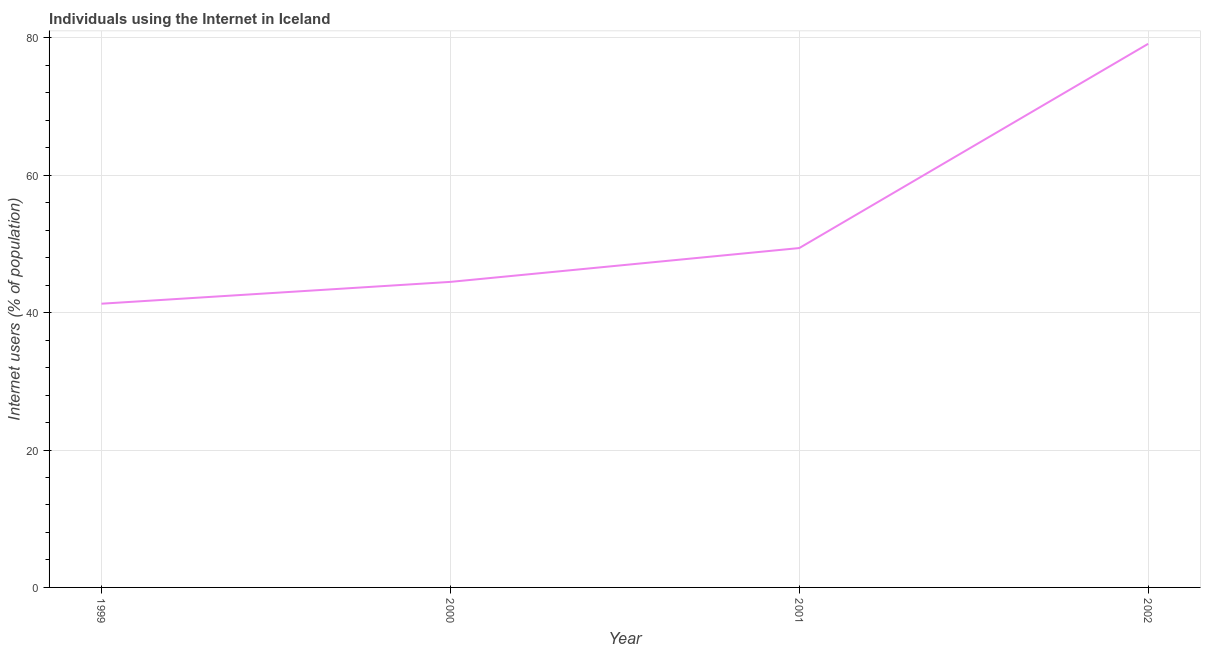What is the number of internet users in 2001?
Ensure brevity in your answer.  49.39. Across all years, what is the maximum number of internet users?
Give a very brief answer. 79.12. Across all years, what is the minimum number of internet users?
Ensure brevity in your answer.  41.29. What is the sum of the number of internet users?
Offer a very short reply. 214.28. What is the difference between the number of internet users in 1999 and 2000?
Ensure brevity in your answer.  -3.18. What is the average number of internet users per year?
Provide a short and direct response. 53.57. What is the median number of internet users?
Your answer should be compact. 46.93. In how many years, is the number of internet users greater than 16 %?
Your answer should be compact. 4. Do a majority of the years between 2001 and 2002 (inclusive) have number of internet users greater than 76 %?
Provide a succinct answer. No. What is the ratio of the number of internet users in 1999 to that in 2000?
Make the answer very short. 0.93. Is the number of internet users in 1999 less than that in 2000?
Your response must be concise. Yes. What is the difference between the highest and the second highest number of internet users?
Your answer should be very brief. 29.73. What is the difference between the highest and the lowest number of internet users?
Your response must be concise. 37.83. In how many years, is the number of internet users greater than the average number of internet users taken over all years?
Offer a very short reply. 1. Does the number of internet users monotonically increase over the years?
Your answer should be compact. Yes. How many years are there in the graph?
Make the answer very short. 4. What is the difference between two consecutive major ticks on the Y-axis?
Provide a short and direct response. 20. Does the graph contain any zero values?
Ensure brevity in your answer.  No. What is the title of the graph?
Offer a terse response. Individuals using the Internet in Iceland. What is the label or title of the X-axis?
Your answer should be very brief. Year. What is the label or title of the Y-axis?
Your answer should be compact. Internet users (% of population). What is the Internet users (% of population) of 1999?
Your answer should be compact. 41.29. What is the Internet users (% of population) in 2000?
Keep it short and to the point. 44.47. What is the Internet users (% of population) of 2001?
Provide a short and direct response. 49.39. What is the Internet users (% of population) of 2002?
Offer a very short reply. 79.12. What is the difference between the Internet users (% of population) in 1999 and 2000?
Your answer should be compact. -3.18. What is the difference between the Internet users (% of population) in 1999 and 2001?
Provide a short and direct response. -8.1. What is the difference between the Internet users (% of population) in 1999 and 2002?
Ensure brevity in your answer.  -37.83. What is the difference between the Internet users (% of population) in 2000 and 2001?
Ensure brevity in your answer.  -4.92. What is the difference between the Internet users (% of population) in 2000 and 2002?
Keep it short and to the point. -34.65. What is the difference between the Internet users (% of population) in 2001 and 2002?
Your answer should be very brief. -29.73. What is the ratio of the Internet users (% of population) in 1999 to that in 2000?
Provide a short and direct response. 0.93. What is the ratio of the Internet users (% of population) in 1999 to that in 2001?
Your answer should be very brief. 0.84. What is the ratio of the Internet users (% of population) in 1999 to that in 2002?
Make the answer very short. 0.52. What is the ratio of the Internet users (% of population) in 2000 to that in 2002?
Provide a succinct answer. 0.56. What is the ratio of the Internet users (% of population) in 2001 to that in 2002?
Offer a terse response. 0.62. 